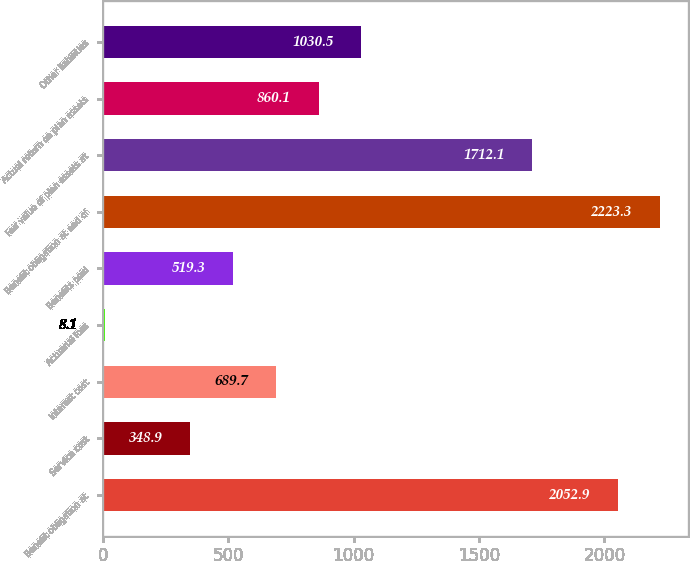Convert chart to OTSL. <chart><loc_0><loc_0><loc_500><loc_500><bar_chart><fcel>Benefit obligation at<fcel>Service cost<fcel>Interest cost<fcel>Actuarial loss<fcel>Benefits paid<fcel>Benefit obligation at end of<fcel>Fair value of plan assets at<fcel>Actual return on plan assets<fcel>Other liabilities<nl><fcel>2052.9<fcel>348.9<fcel>689.7<fcel>8.1<fcel>519.3<fcel>2223.3<fcel>1712.1<fcel>860.1<fcel>1030.5<nl></chart> 